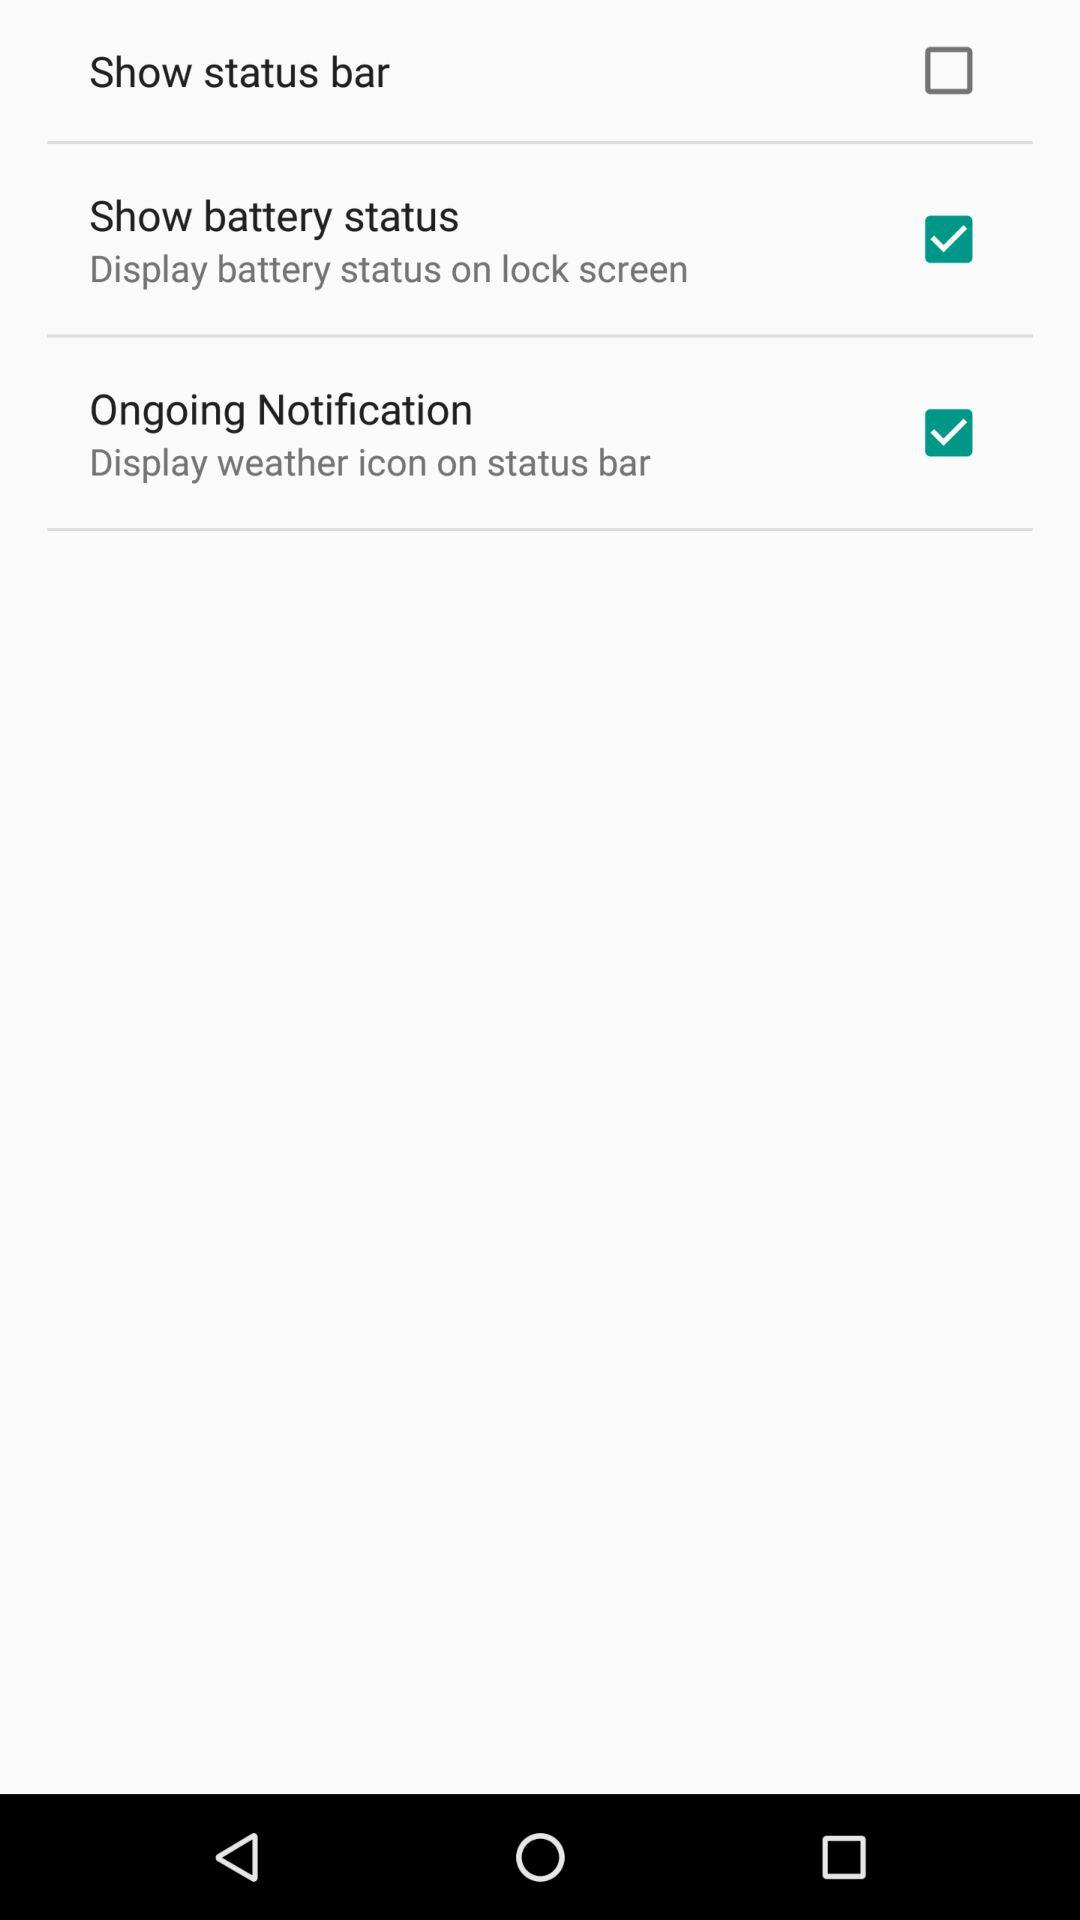Which options are checked for settings? The checked options are "Show battery status" and "Ongoing Notification". 